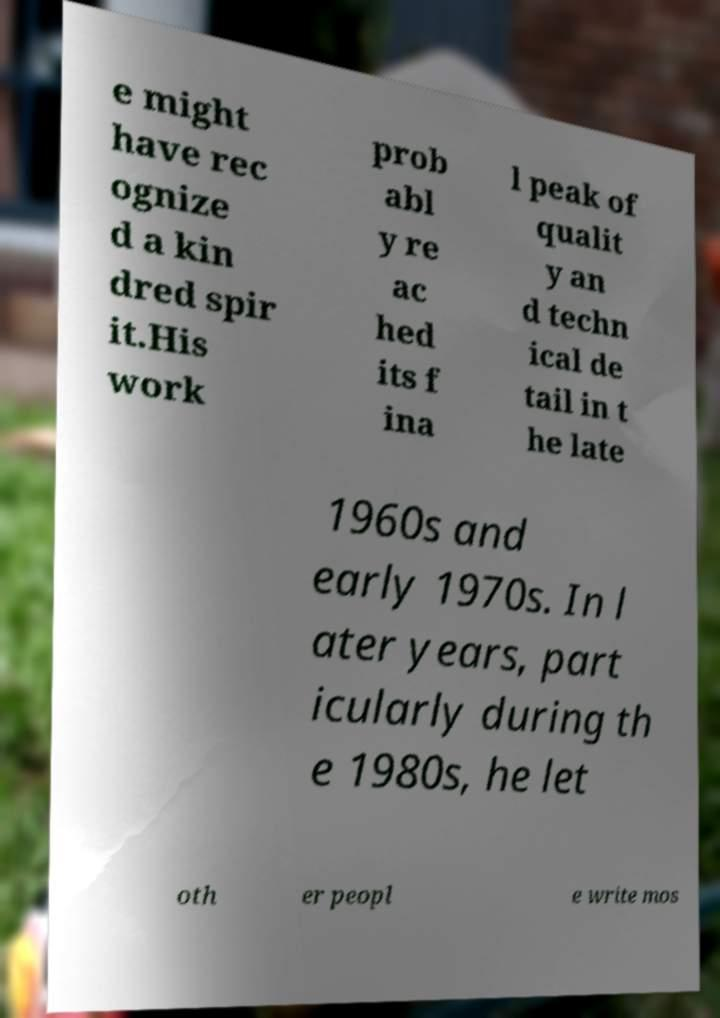What messages or text are displayed in this image? I need them in a readable, typed format. e might have rec ognize d a kin dred spir it.His work prob abl y re ac hed its f ina l peak of qualit y an d techn ical de tail in t he late 1960s and early 1970s. In l ater years, part icularly during th e 1980s, he let oth er peopl e write mos 